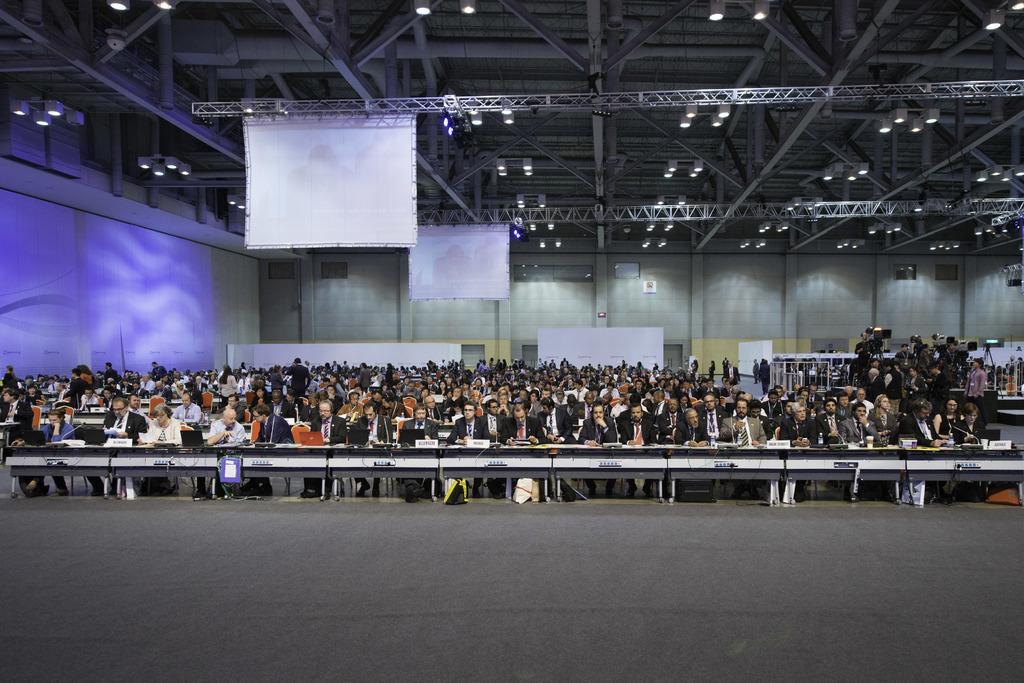Describe this image in one or two sentences. This picture is an inside view of a room. In the center of the image we can see a group of people are sitting on a chair, in-front of them tables are there. On the tables we can see laptops, boards, mics. In the background of the image we can see wall, screen, camera stand. At the top of the image we can see roof and lights. At the bottom of the image we can see the floor. 